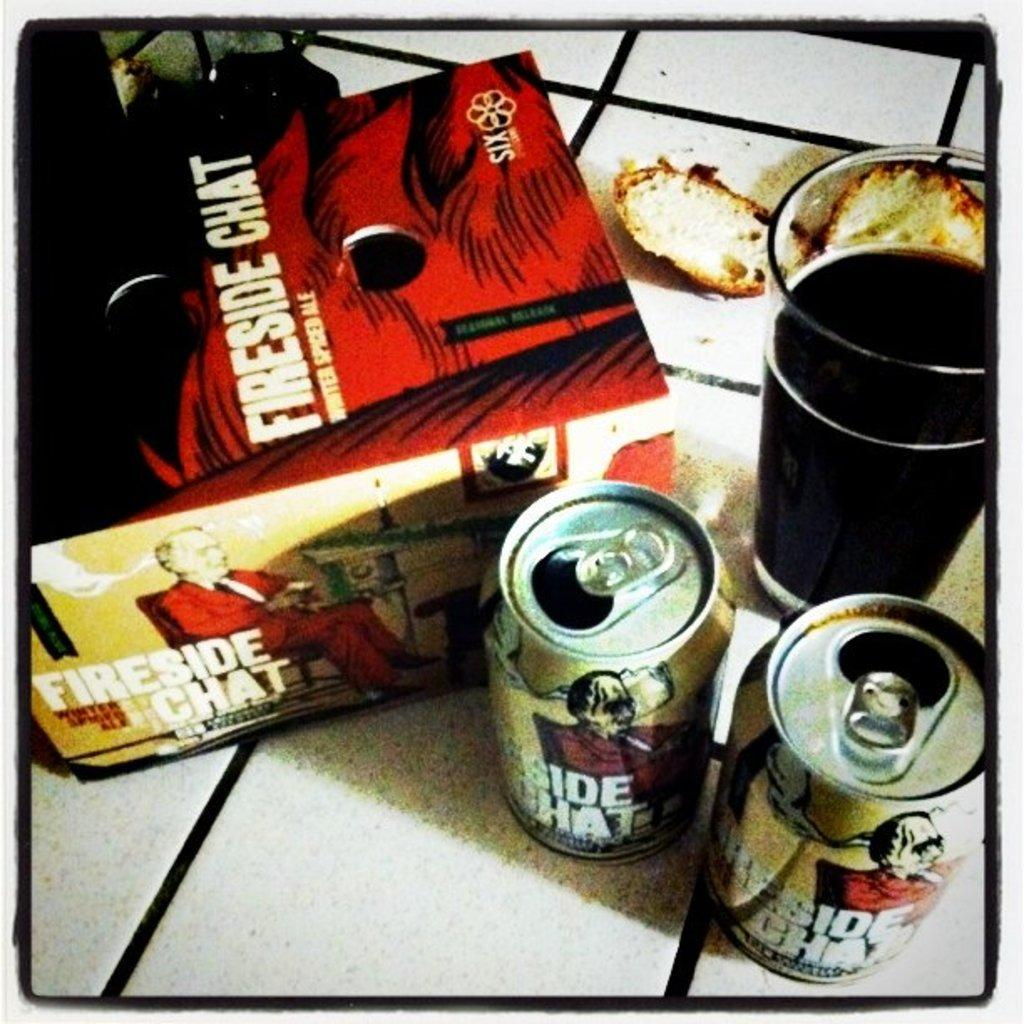<image>
Present a compact description of the photo's key features. The type of drink in the can is called Fireside Chat 